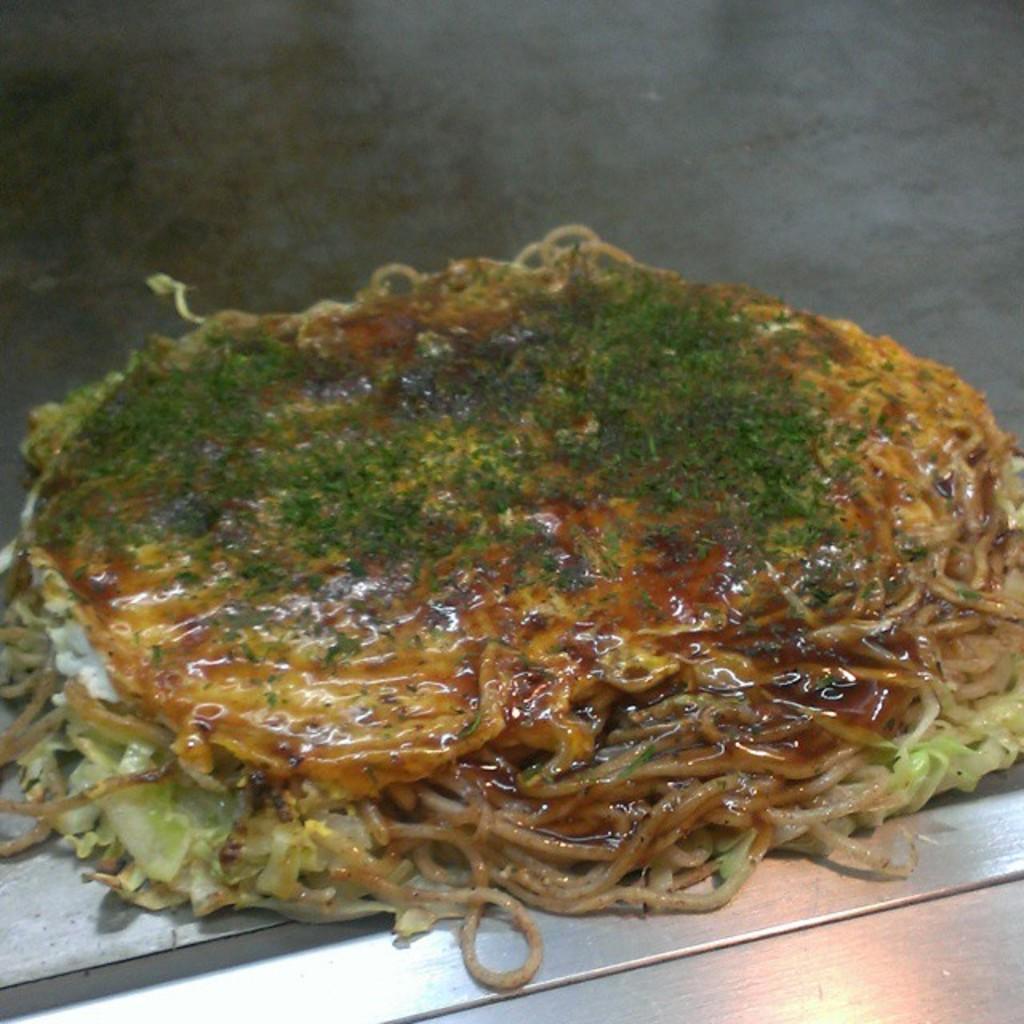Please provide a concise description of this image. In this image I can see noodles and on it I can see green color thing. 